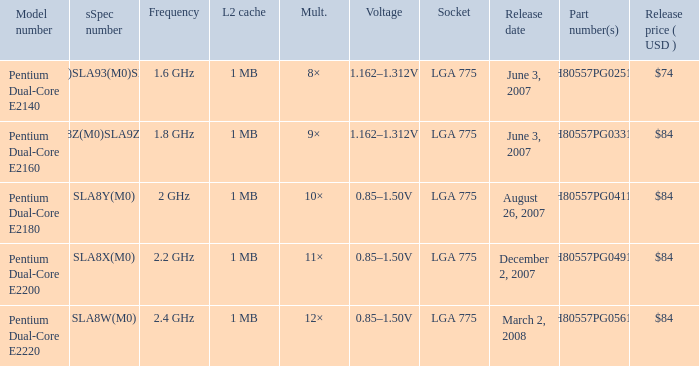What's the release price (USD) for part number hh80557pg0491m? $84. Could you help me parse every detail presented in this table? {'header': ['Model number', 'sSpec number', 'Frequency', 'L2 cache', 'Mult.', 'Voltage', 'Socket', 'Release date', 'Part number(s)', 'Release price ( USD )'], 'rows': [['Pentium Dual-Core E2140', 'SLA3J(L2)SLA93(M0)SLALS(G0)', '1.6 GHz', '1 MB', '8×', '1.162–1.312V', 'LGA 775', 'June 3, 2007', 'HH80557PG0251M', '$74'], ['Pentium Dual-Core E2160', 'SLA3H(L2)SLA8Z(M0)SLA9Z(G0)SLASX(G0)', '1.8 GHz', '1 MB', '9×', '1.162–1.312V', 'LGA 775', 'June 3, 2007', 'HH80557PG0331M', '$84'], ['Pentium Dual-Core E2180', 'SLA8Y(M0)', '2 GHz', '1 MB', '10×', '0.85–1.50V', 'LGA 775', 'August 26, 2007', 'HH80557PG0411M', '$84'], ['Pentium Dual-Core E2200', 'SLA8X(M0)', '2.2 GHz', '1 MB', '11×', '0.85–1.50V', 'LGA 775', 'December 2, 2007', 'HH80557PG0491M', '$84'], ['Pentium Dual-Core E2220', 'SLA8W(M0)', '2.4 GHz', '1 MB', '12×', '0.85–1.50V', 'LGA 775', 'March 2, 2008', 'HH80557PG0561M', '$84']]} 